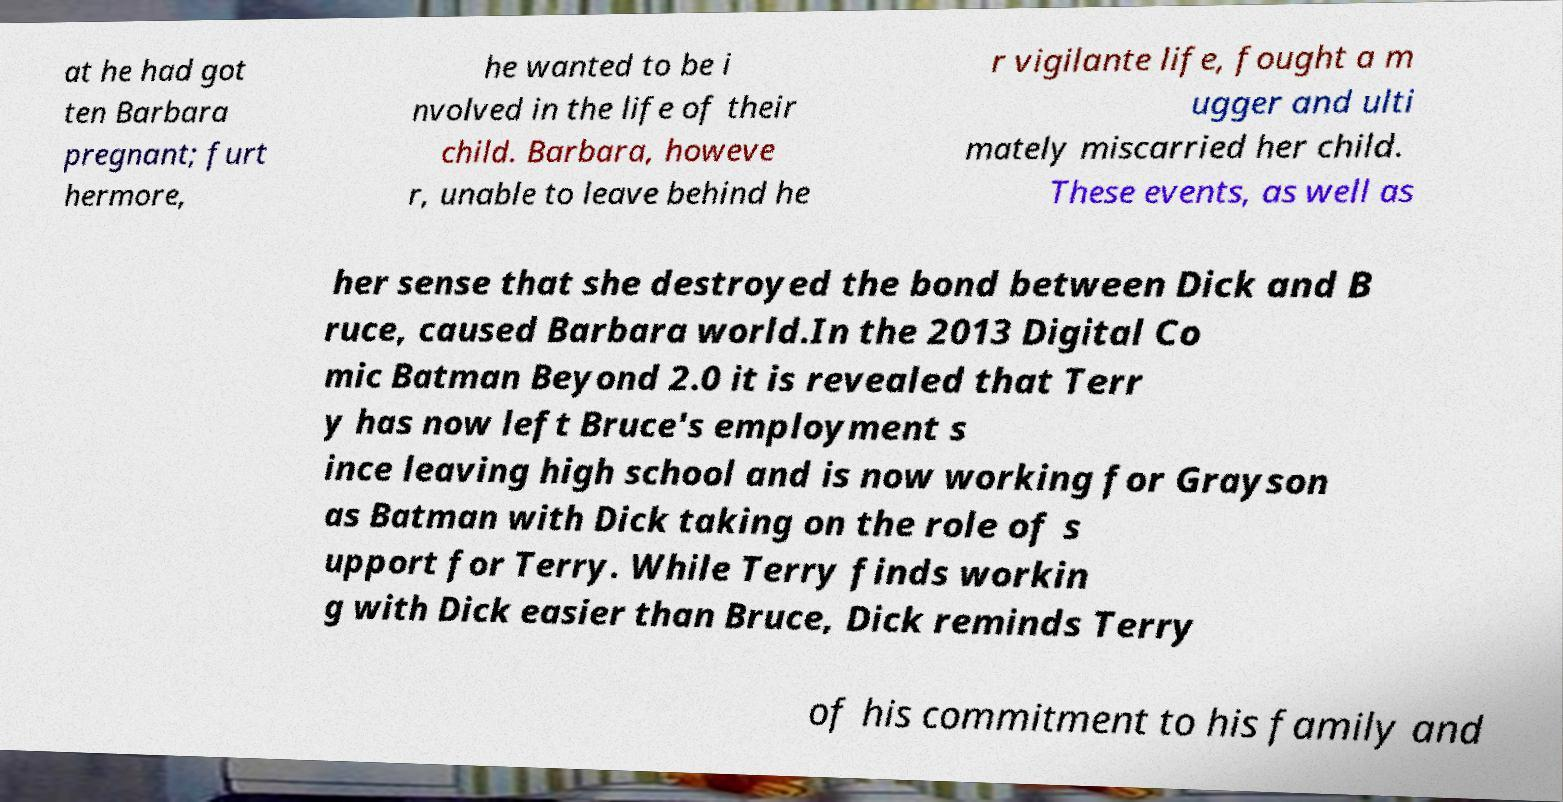Could you extract and type out the text from this image? at he had got ten Barbara pregnant; furt hermore, he wanted to be i nvolved in the life of their child. Barbara, howeve r, unable to leave behind he r vigilante life, fought a m ugger and ulti mately miscarried her child. These events, as well as her sense that she destroyed the bond between Dick and B ruce, caused Barbara world.In the 2013 Digital Co mic Batman Beyond 2.0 it is revealed that Terr y has now left Bruce's employment s ince leaving high school and is now working for Grayson as Batman with Dick taking on the role of s upport for Terry. While Terry finds workin g with Dick easier than Bruce, Dick reminds Terry of his commitment to his family and 